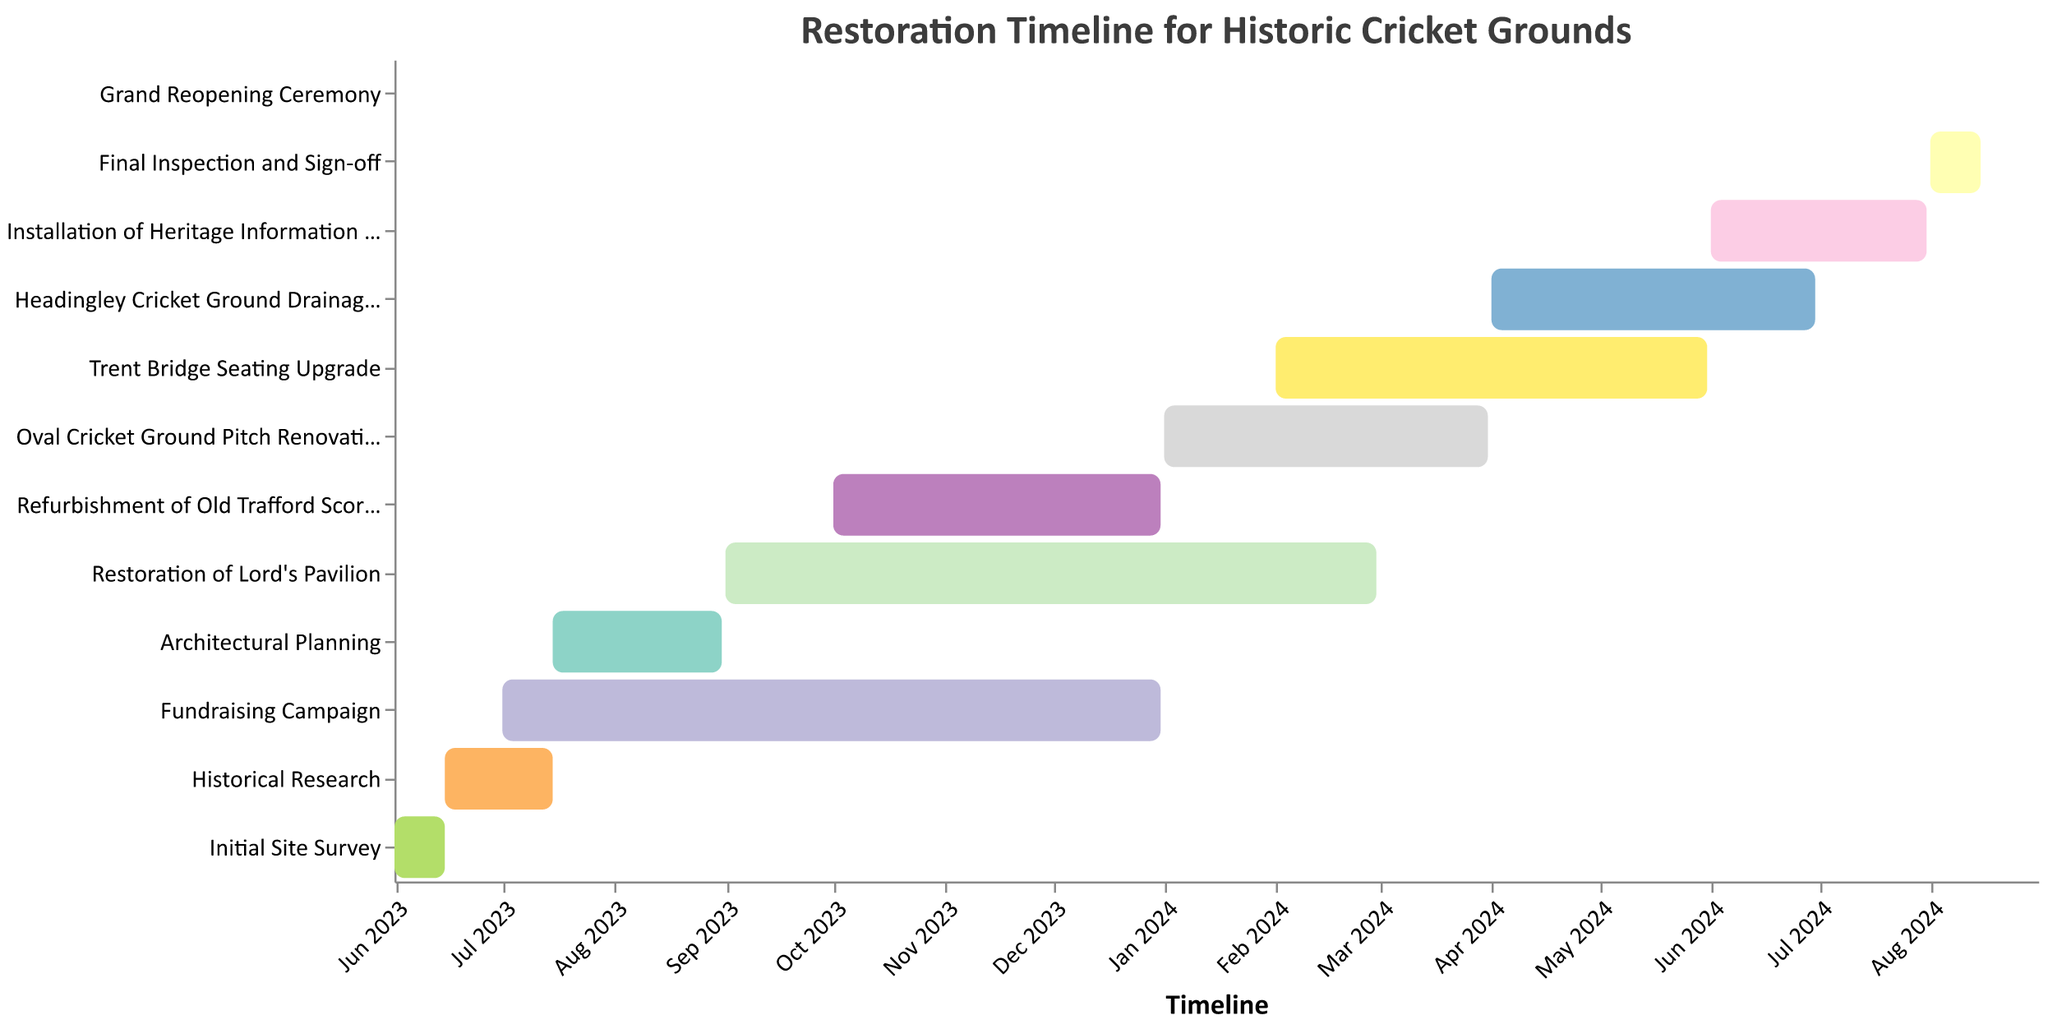What is the title of the chart? The title of the chart is typically found at the top of the figure. In this case, it is displayed prominently.
Answer: Restoration Timeline for Historic Cricket Grounds How long is the "Initial Site Survey" scheduled to last? To figure out the duration of the "Initial Site Survey," subtract the start date from the end date: June 15, 2023 - June 1, 2023.
Answer: 14 days Which tasks are expected to be active in December 2023? Examine the bars that span across December 2023 or have "End Date" in December 2023. "Fundraising Campaign" (July 2023 - December 2023) and "Refurbishment of Old Trafford Scoreboard" (October 2023 - December 2023) are active during this period.
Answer: Fundraising Campaign, Refurbishment of Old Trafford Scoreboard How many tasks have their end date in 2024? Look for tasks that have "End Date" in 2024. Count the number of tasks from the chart: Restoration of Lord's Pavilion, Oval Cricket Ground Pitch Renovation, Trent Bridge Seating Upgrade, Headingley Cricket Ground Drainage Improvement, Installation of Heritage Information Displays, Final Inspection and Sign-off, Grand Reopening Ceremony.
Answer: 7 tasks Which task runs the longest? Compare the duration of all tasks by calculating the difference between the start and end dates for each task. The longest duration is the "Fundraising Campaign" which runs from July 2023 to December 2023, equating to 6 months.
Answer: Fundraising Campaign When does the "Fundraising Campaign" start and end? By referring to the "Fundraising Campaign" bar on the chart, this task starts on July 1, 2023, and ends on December 31, 2023.
Answer: July 1, 2023 to December 31, 2023 What two tasks are scheduled to start in June 2023? Look for the bars with a starting date in June 2023. The two tasks are "Initial Site Survey" and "Historical Research".
Answer: Initial Site Survey, Historical Research Which tasks overlap with the "Restoration of Lord's Pavilion"? Examine the timeline of the "Restoration of Lord's Pavilion" which runs from September 2023 to February 2024. Cross-check other tasks in the same period: Fundraising Campaign, Refurbishment of Old Trafford Scoreboard, and Oval Cricket Ground Pitch Renovation.
Answer: Fundraising Campaign, Refurbishment of Old Trafford Scoreboard, Oval Cricket Ground Pitch Renovation What is the last scheduled task for the project? The last task scheduled in the timeline is the "Grand Reopening Ceremony" which is held on August 31, 2024.
Answer: Grand Reopening Ceremony 